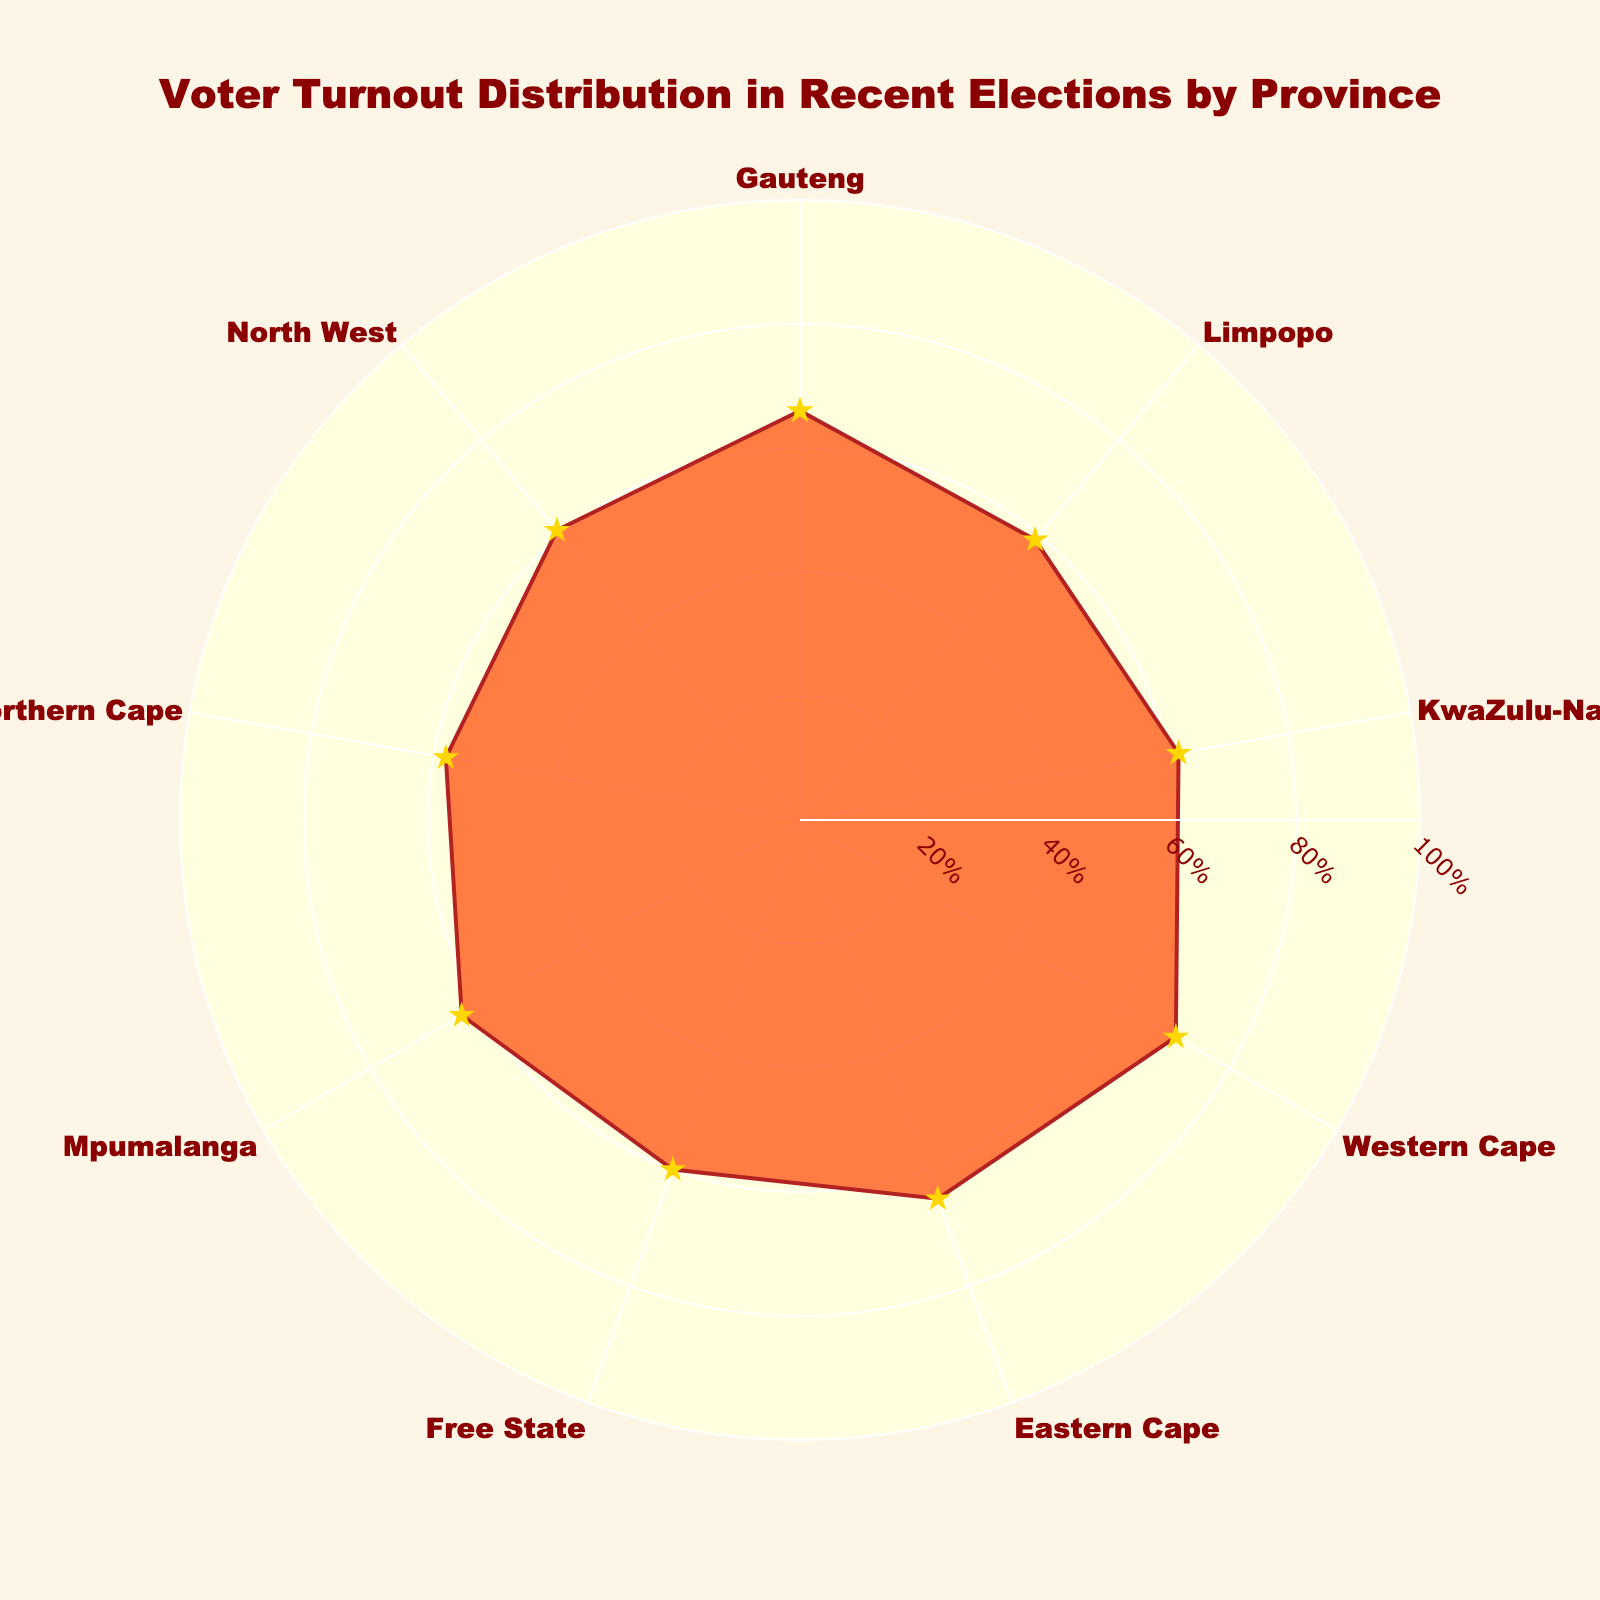What is the title of the chart? The title is usually displayed at the top center of the chart, and it provides a summary of what the chart is about.
Answer: Voter Turnout Distribution in Recent Elections by Province Which province has the highest voter turnout percentage? The highest point on the rose chart corresponds to the province with the highest voter turnout, marked with a longer radius.
Answer: Western Cape What are the provinces with a voter turnout percentage below 60%? Identify the portions of the rose chart where the radius is less than 60. These segments correspond to the provinces with under 60% voter turnout.
Answer: Limpopo, Northern Cape How many provinces have a voter turnout percentage between 60% and 65%? Count the segments on the rose chart where the radius falls between 60% and 65%. These values represent provinces with voter turnout within that range.
Answer: Four provinces What's the average voter turnout percentage across all provinces? Sum all the voter turnout percentages and then divide by the total number of provinces (9). This gives the average value.
Answer: 62.67% How does the voter turnout in Gauteng compare to that in Mpumalanga? Compare the lengths of the radii corresponding to Gauteng and Mpumalanga.
Answer: Gauteng has a higher voter turnout than Mpumalanga What is the median voter turnout percentage? Arrange the voter turnout percentages in ascending order, and identify the middle value. Since there are 9 values, the fifth value is the median.
Answer: 62% Which province has the lowest voter turnout percentage, and what is it? The province with the shortest radius on the rose chart corresponds to the lowest voter turnout.
Answer: Northern Cape, 58% Are there any provinces with equal voter turnout percentages? Check if there are any segments on the rose chart that have the same radius lengths, indicating equal values.
Answer: No Which provinces have voter turnout percentages between the 60% mark and the highest recorded turnout? Identify the segments extending from the 60% radius to the longest radius on the rose chart. These correspond to provinces within that range.
Answer: Free State, North West, KwaZulu-Natal, Mpumalanga, Gauteng, Eastern Cape, Western Cape 